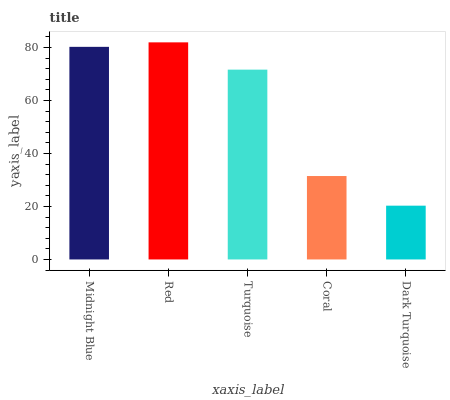Is Dark Turquoise the minimum?
Answer yes or no. Yes. Is Red the maximum?
Answer yes or no. Yes. Is Turquoise the minimum?
Answer yes or no. No. Is Turquoise the maximum?
Answer yes or no. No. Is Red greater than Turquoise?
Answer yes or no. Yes. Is Turquoise less than Red?
Answer yes or no. Yes. Is Turquoise greater than Red?
Answer yes or no. No. Is Red less than Turquoise?
Answer yes or no. No. Is Turquoise the high median?
Answer yes or no. Yes. Is Turquoise the low median?
Answer yes or no. Yes. Is Dark Turquoise the high median?
Answer yes or no. No. Is Coral the low median?
Answer yes or no. No. 